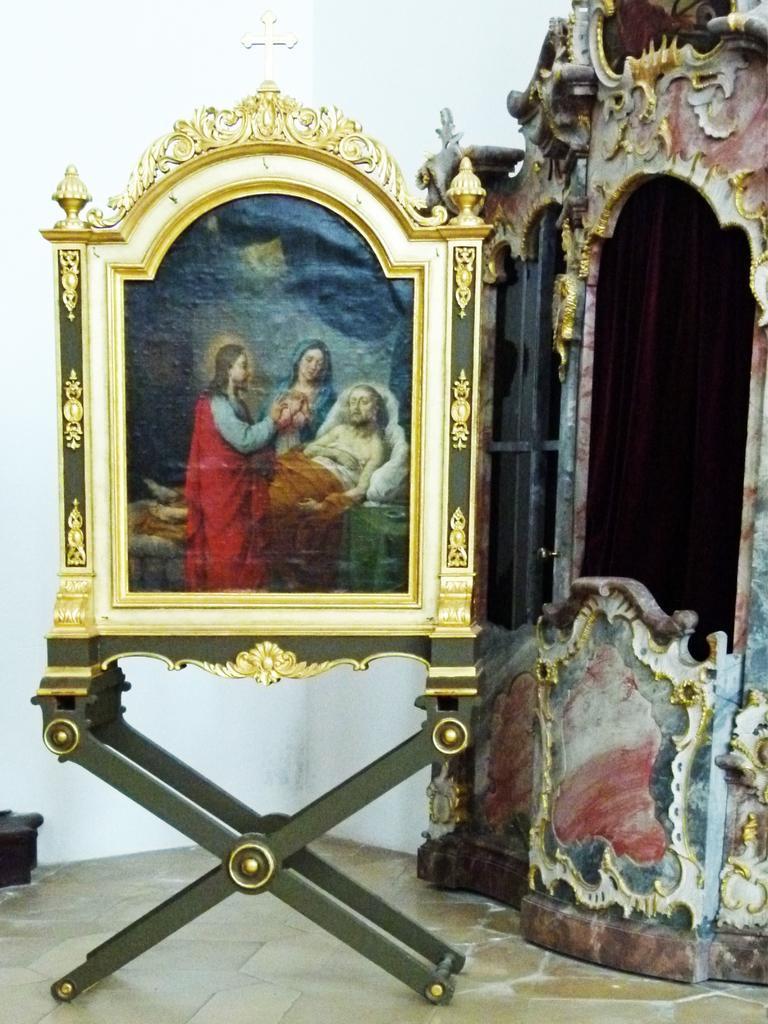What is the main object in the image? There is a picture frame on a stand in the image. What is inside the picture frame? The picture frame contains pictures of persons. What is visible behind the picture frame? There is a wall behind the picture frame. Are there any other decorative items on the wall? Yes, there is a sculpture on the wall to the right of the picture frame. What is the surprise in the image? There is no surprise present in the image. 